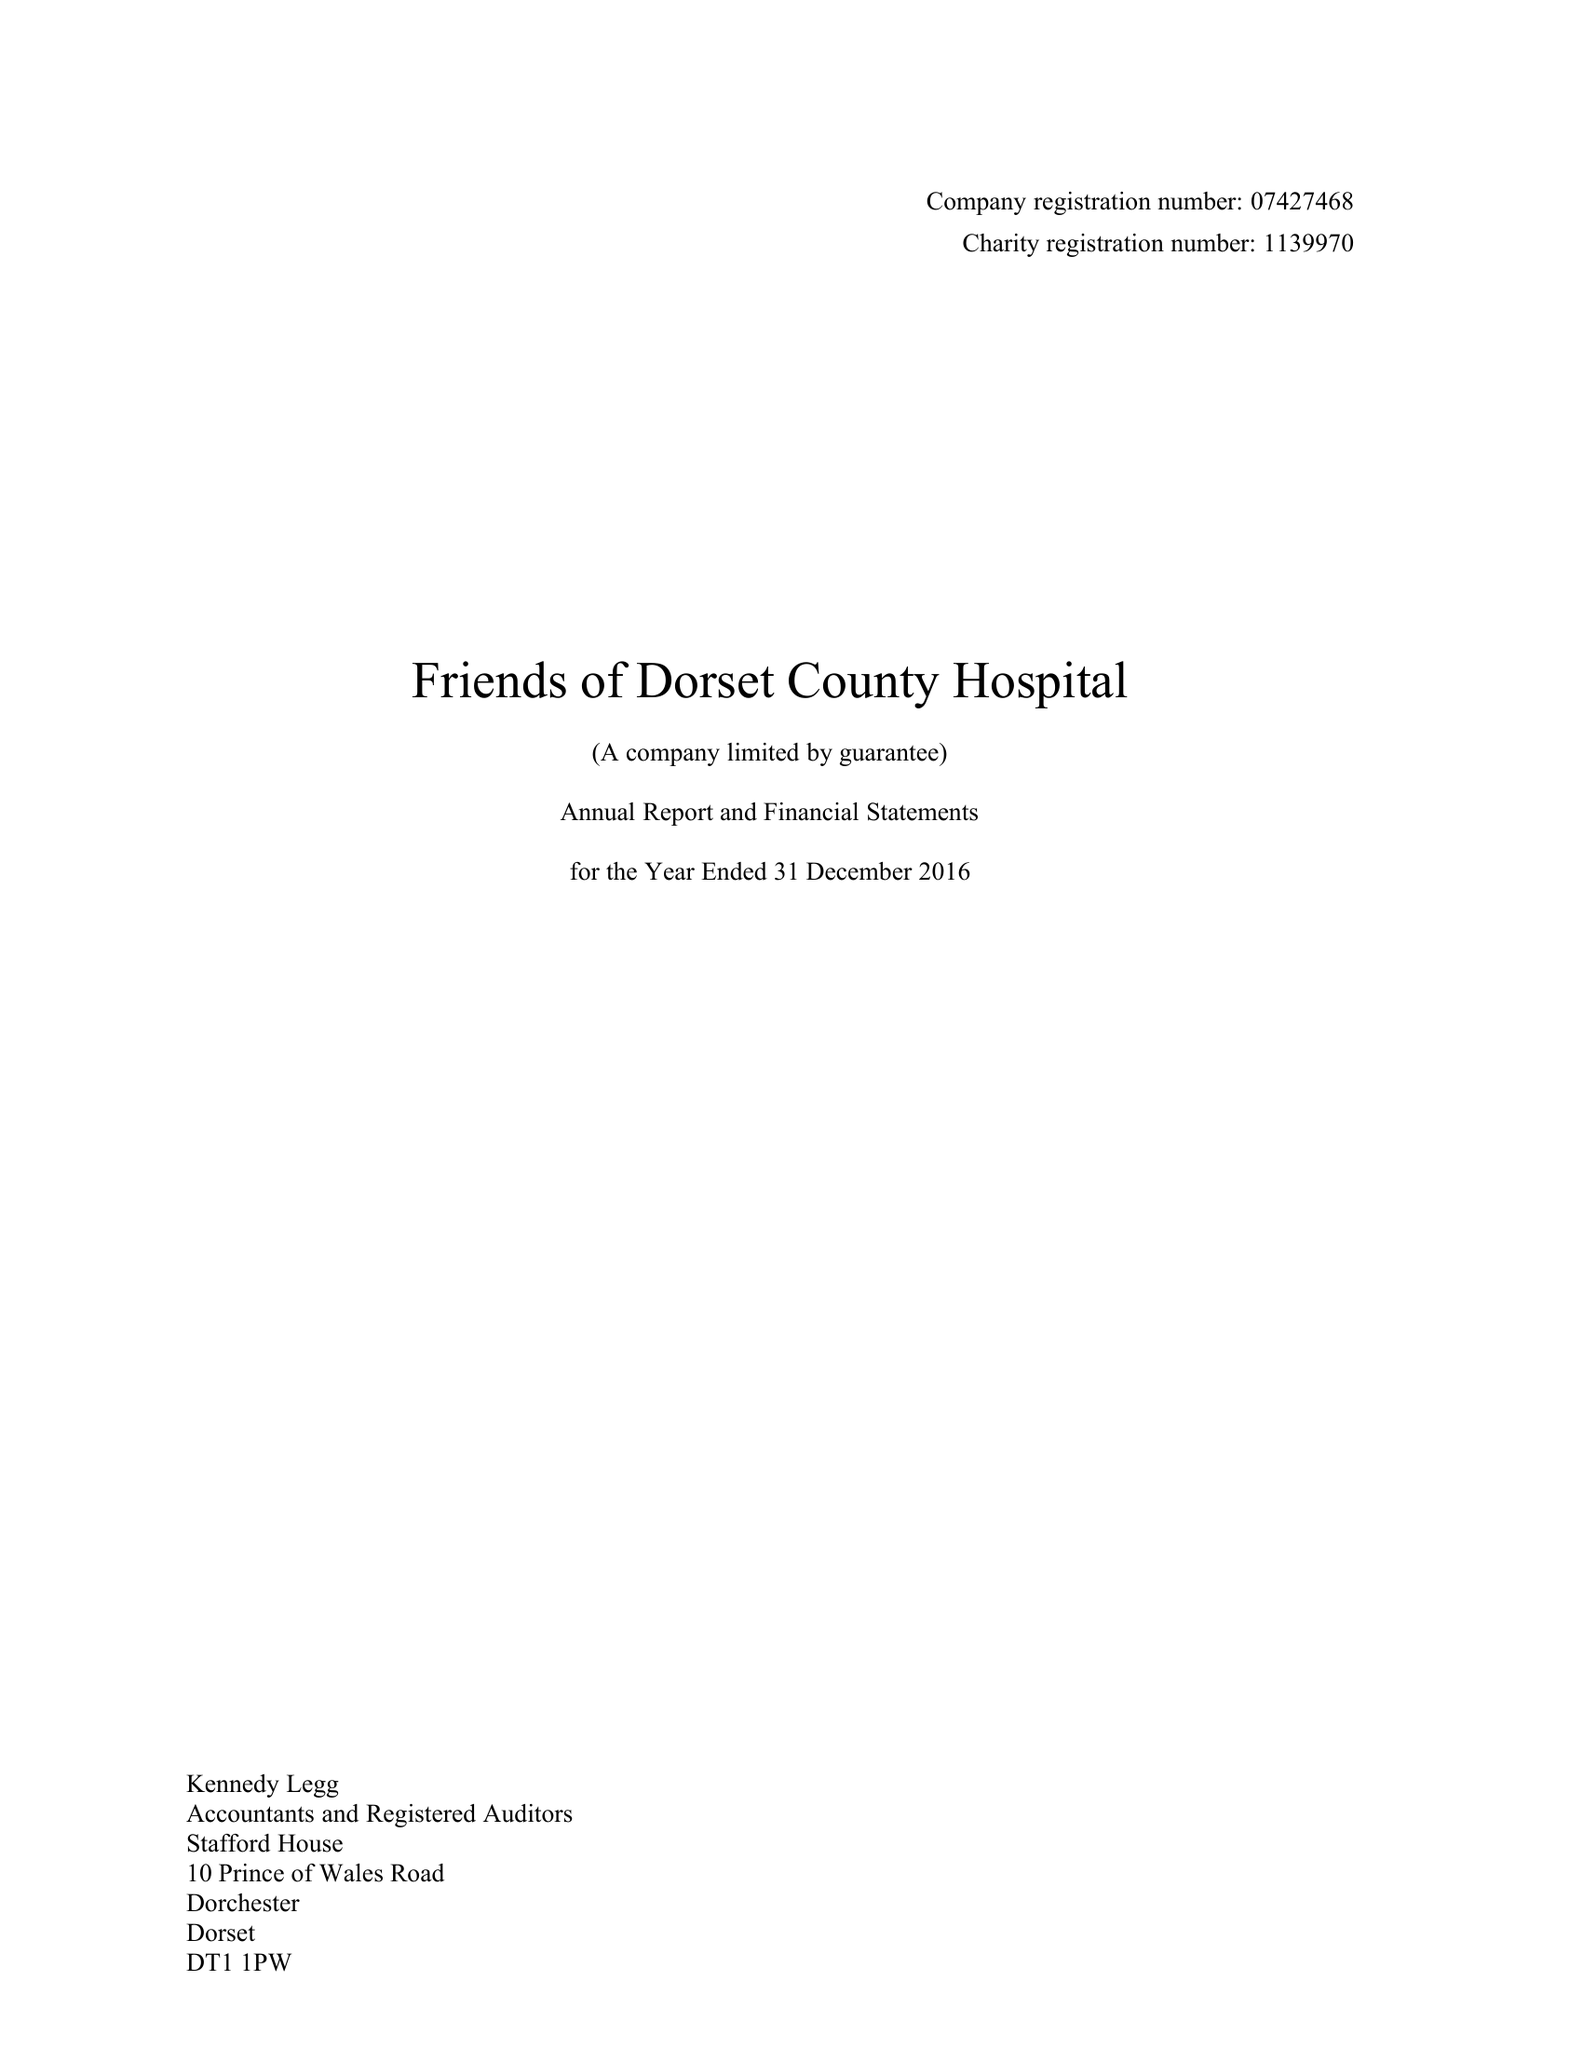What is the value for the charity_number?
Answer the question using a single word or phrase. 1139970 